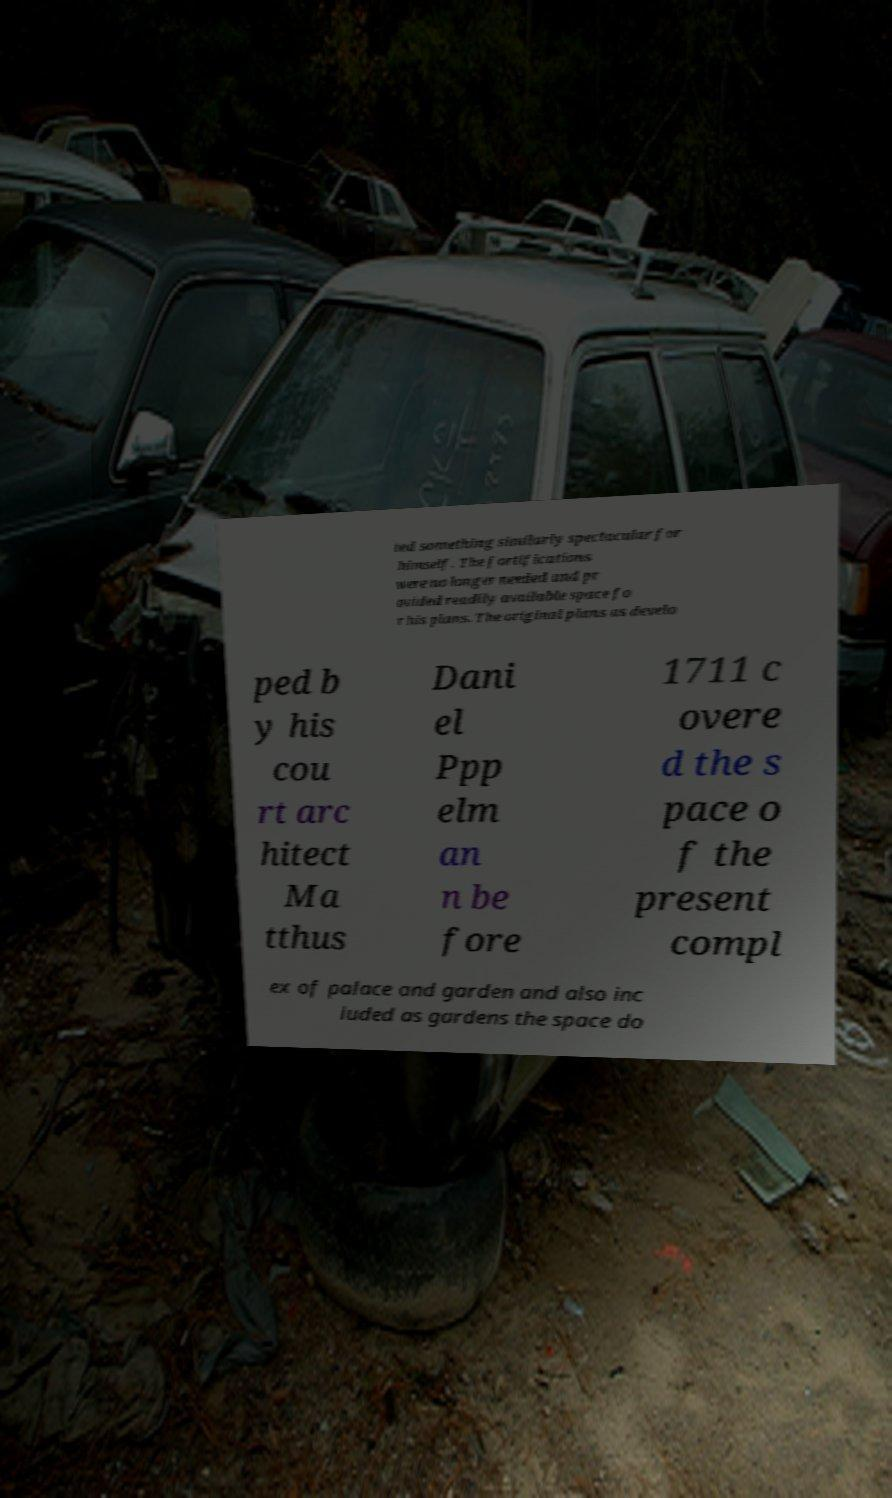I need the written content from this picture converted into text. Can you do that? ted something similarly spectacular for himself. The fortifications were no longer needed and pr ovided readily available space fo r his plans. The original plans as develo ped b y his cou rt arc hitect Ma tthus Dani el Ppp elm an n be fore 1711 c overe d the s pace o f the present compl ex of palace and garden and also inc luded as gardens the space do 